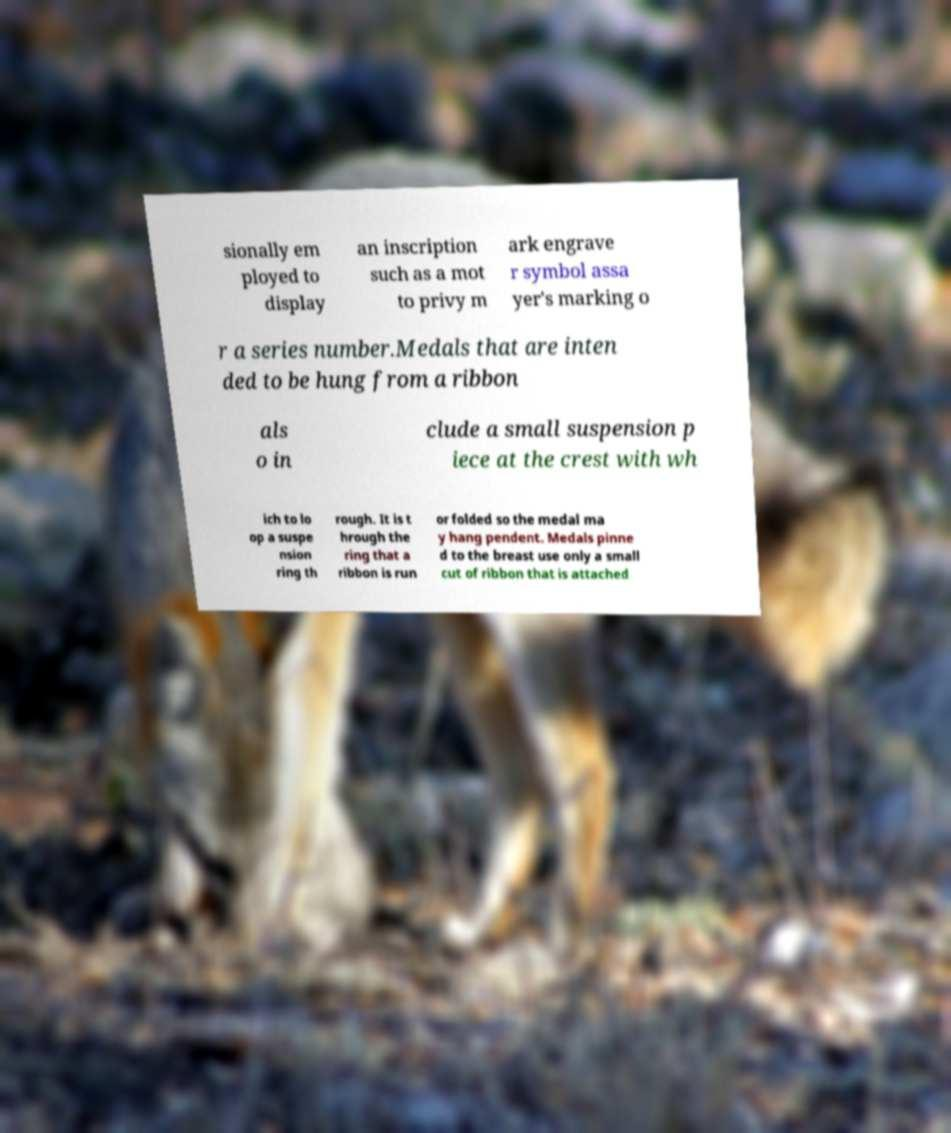Could you assist in decoding the text presented in this image and type it out clearly? sionally em ployed to display an inscription such as a mot to privy m ark engrave r symbol assa yer's marking o r a series number.Medals that are inten ded to be hung from a ribbon als o in clude a small suspension p iece at the crest with wh ich to lo op a suspe nsion ring th rough. It is t hrough the ring that a ribbon is run or folded so the medal ma y hang pendent. Medals pinne d to the breast use only a small cut of ribbon that is attached 